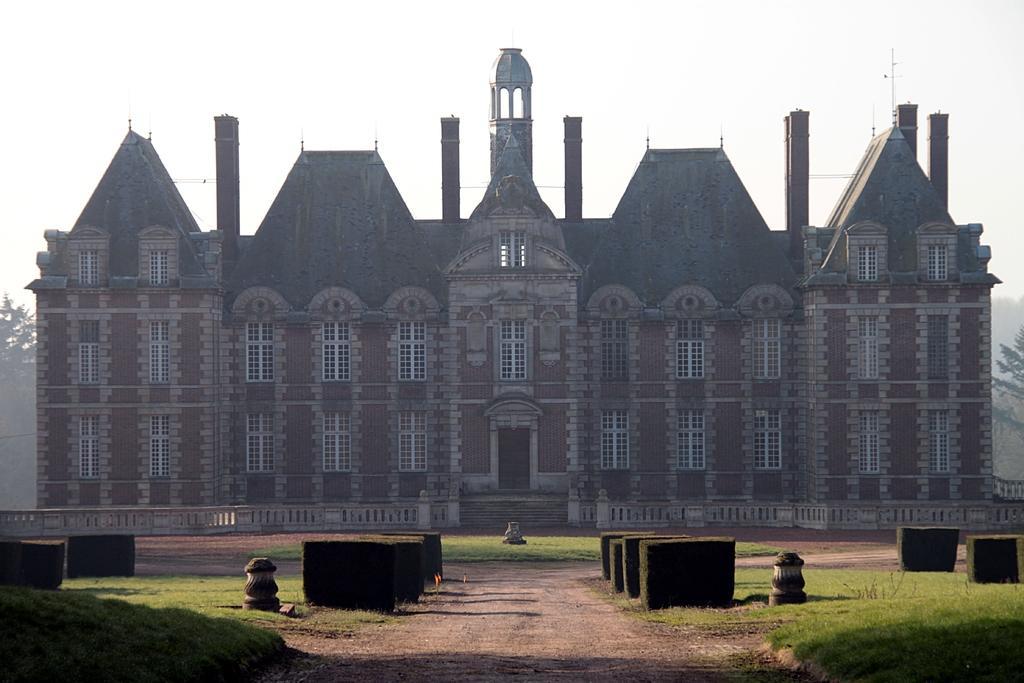Describe this image in one or two sentences. In this picture we can see a building, in front of the building we can see grass, in the background we can find few trees. 